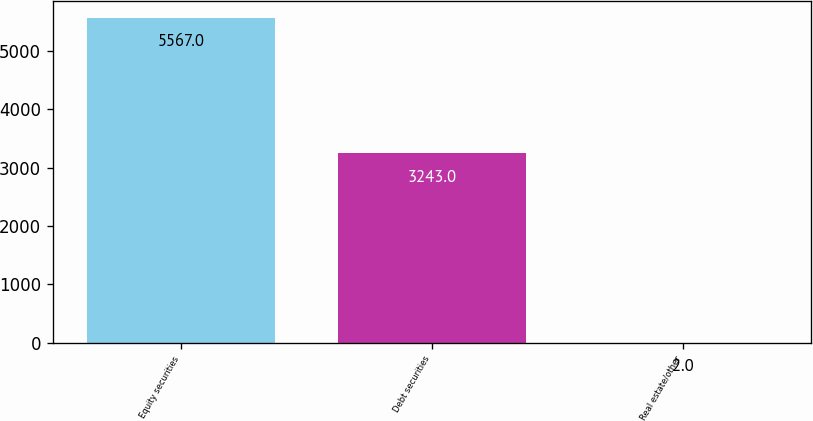Convert chart. <chart><loc_0><loc_0><loc_500><loc_500><bar_chart><fcel>Equity securities<fcel>Debt securities<fcel>Real estate/other<nl><fcel>5567<fcel>3243<fcel>2<nl></chart> 